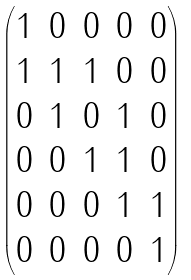Convert formula to latex. <formula><loc_0><loc_0><loc_500><loc_500>\begin{pmatrix} 1 & 0 & 0 & 0 & 0 \\ 1 & 1 & 1 & 0 & 0 \\ 0 & 1 & 0 & 1 & 0 \\ 0 & 0 & 1 & 1 & 0 \\ 0 & 0 & 0 & 1 & 1 \\ 0 & 0 & 0 & 0 & 1 \end{pmatrix}</formula> 